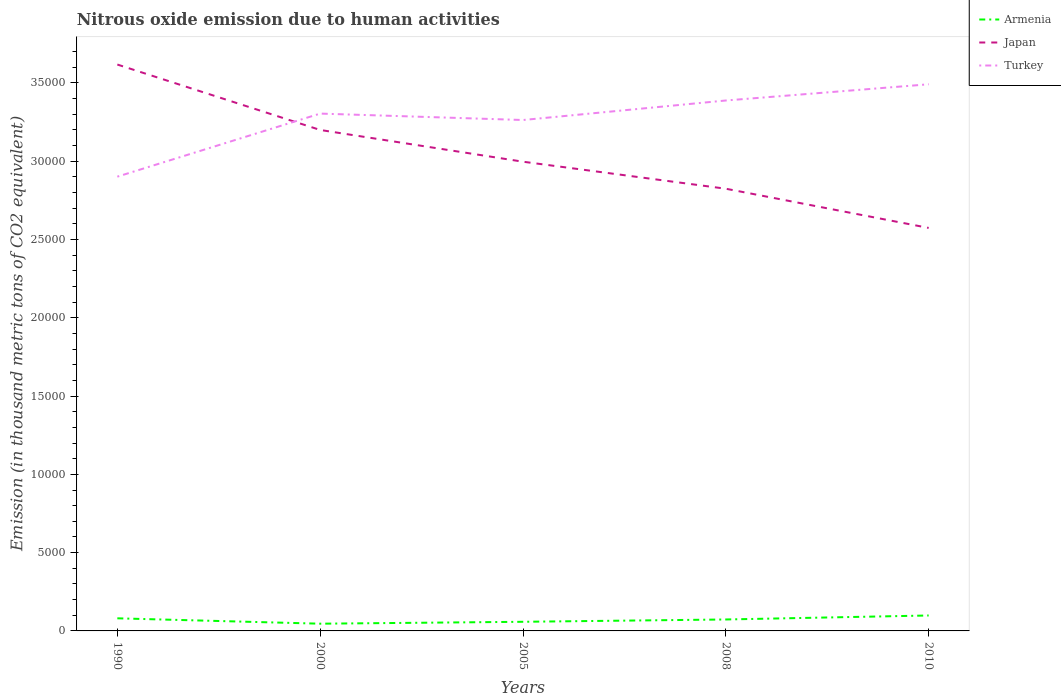How many different coloured lines are there?
Make the answer very short. 3. Does the line corresponding to Japan intersect with the line corresponding to Armenia?
Provide a succinct answer. No. Is the number of lines equal to the number of legend labels?
Your response must be concise. Yes. Across all years, what is the maximum amount of nitrous oxide emitted in Armenia?
Keep it short and to the point. 461.6. In which year was the amount of nitrous oxide emitted in Armenia maximum?
Provide a short and direct response. 2000. What is the total amount of nitrous oxide emitted in Japan in the graph?
Offer a very short reply. 1725.6. What is the difference between the highest and the second highest amount of nitrous oxide emitted in Turkey?
Ensure brevity in your answer.  5899.6. What is the difference between the highest and the lowest amount of nitrous oxide emitted in Turkey?
Give a very brief answer. 3. Is the amount of nitrous oxide emitted in Japan strictly greater than the amount of nitrous oxide emitted in Turkey over the years?
Your response must be concise. No. How many years are there in the graph?
Keep it short and to the point. 5. Are the values on the major ticks of Y-axis written in scientific E-notation?
Your answer should be compact. No. Does the graph contain any zero values?
Your response must be concise. No. How many legend labels are there?
Ensure brevity in your answer.  3. How are the legend labels stacked?
Offer a terse response. Vertical. What is the title of the graph?
Make the answer very short. Nitrous oxide emission due to human activities. What is the label or title of the X-axis?
Your answer should be very brief. Years. What is the label or title of the Y-axis?
Your response must be concise. Emission (in thousand metric tons of CO2 equivalent). What is the Emission (in thousand metric tons of CO2 equivalent) of Armenia in 1990?
Give a very brief answer. 805. What is the Emission (in thousand metric tons of CO2 equivalent) of Japan in 1990?
Provide a short and direct response. 3.62e+04. What is the Emission (in thousand metric tons of CO2 equivalent) in Turkey in 1990?
Your answer should be compact. 2.90e+04. What is the Emission (in thousand metric tons of CO2 equivalent) in Armenia in 2000?
Provide a succinct answer. 461.6. What is the Emission (in thousand metric tons of CO2 equivalent) of Japan in 2000?
Give a very brief answer. 3.20e+04. What is the Emission (in thousand metric tons of CO2 equivalent) of Turkey in 2000?
Provide a short and direct response. 3.30e+04. What is the Emission (in thousand metric tons of CO2 equivalent) in Armenia in 2005?
Keep it short and to the point. 583.5. What is the Emission (in thousand metric tons of CO2 equivalent) in Japan in 2005?
Provide a short and direct response. 3.00e+04. What is the Emission (in thousand metric tons of CO2 equivalent) of Turkey in 2005?
Give a very brief answer. 3.26e+04. What is the Emission (in thousand metric tons of CO2 equivalent) of Armenia in 2008?
Give a very brief answer. 731.4. What is the Emission (in thousand metric tons of CO2 equivalent) in Japan in 2008?
Your answer should be compact. 2.82e+04. What is the Emission (in thousand metric tons of CO2 equivalent) in Turkey in 2008?
Give a very brief answer. 3.39e+04. What is the Emission (in thousand metric tons of CO2 equivalent) in Armenia in 2010?
Offer a very short reply. 985.9. What is the Emission (in thousand metric tons of CO2 equivalent) of Japan in 2010?
Offer a terse response. 2.57e+04. What is the Emission (in thousand metric tons of CO2 equivalent) of Turkey in 2010?
Your response must be concise. 3.49e+04. Across all years, what is the maximum Emission (in thousand metric tons of CO2 equivalent) in Armenia?
Provide a short and direct response. 985.9. Across all years, what is the maximum Emission (in thousand metric tons of CO2 equivalent) of Japan?
Your answer should be compact. 3.62e+04. Across all years, what is the maximum Emission (in thousand metric tons of CO2 equivalent) of Turkey?
Make the answer very short. 3.49e+04. Across all years, what is the minimum Emission (in thousand metric tons of CO2 equivalent) of Armenia?
Your answer should be very brief. 461.6. Across all years, what is the minimum Emission (in thousand metric tons of CO2 equivalent) of Japan?
Keep it short and to the point. 2.57e+04. Across all years, what is the minimum Emission (in thousand metric tons of CO2 equivalent) in Turkey?
Make the answer very short. 2.90e+04. What is the total Emission (in thousand metric tons of CO2 equivalent) in Armenia in the graph?
Give a very brief answer. 3567.4. What is the total Emission (in thousand metric tons of CO2 equivalent) of Japan in the graph?
Provide a succinct answer. 1.52e+05. What is the total Emission (in thousand metric tons of CO2 equivalent) of Turkey in the graph?
Offer a terse response. 1.63e+05. What is the difference between the Emission (in thousand metric tons of CO2 equivalent) in Armenia in 1990 and that in 2000?
Provide a short and direct response. 343.4. What is the difference between the Emission (in thousand metric tons of CO2 equivalent) in Japan in 1990 and that in 2000?
Provide a short and direct response. 4179.1. What is the difference between the Emission (in thousand metric tons of CO2 equivalent) of Turkey in 1990 and that in 2000?
Ensure brevity in your answer.  -4027.6. What is the difference between the Emission (in thousand metric tons of CO2 equivalent) of Armenia in 1990 and that in 2005?
Your answer should be compact. 221.5. What is the difference between the Emission (in thousand metric tons of CO2 equivalent) in Japan in 1990 and that in 2005?
Provide a succinct answer. 6206.6. What is the difference between the Emission (in thousand metric tons of CO2 equivalent) in Turkey in 1990 and that in 2005?
Your answer should be compact. -3617.4. What is the difference between the Emission (in thousand metric tons of CO2 equivalent) in Armenia in 1990 and that in 2008?
Your answer should be very brief. 73.6. What is the difference between the Emission (in thousand metric tons of CO2 equivalent) in Japan in 1990 and that in 2008?
Your answer should be very brief. 7932.2. What is the difference between the Emission (in thousand metric tons of CO2 equivalent) in Turkey in 1990 and that in 2008?
Keep it short and to the point. -4864.2. What is the difference between the Emission (in thousand metric tons of CO2 equivalent) in Armenia in 1990 and that in 2010?
Provide a short and direct response. -180.9. What is the difference between the Emission (in thousand metric tons of CO2 equivalent) in Japan in 1990 and that in 2010?
Your answer should be compact. 1.04e+04. What is the difference between the Emission (in thousand metric tons of CO2 equivalent) of Turkey in 1990 and that in 2010?
Provide a short and direct response. -5899.6. What is the difference between the Emission (in thousand metric tons of CO2 equivalent) in Armenia in 2000 and that in 2005?
Keep it short and to the point. -121.9. What is the difference between the Emission (in thousand metric tons of CO2 equivalent) in Japan in 2000 and that in 2005?
Offer a terse response. 2027.5. What is the difference between the Emission (in thousand metric tons of CO2 equivalent) in Turkey in 2000 and that in 2005?
Provide a succinct answer. 410.2. What is the difference between the Emission (in thousand metric tons of CO2 equivalent) in Armenia in 2000 and that in 2008?
Your answer should be compact. -269.8. What is the difference between the Emission (in thousand metric tons of CO2 equivalent) of Japan in 2000 and that in 2008?
Your answer should be compact. 3753.1. What is the difference between the Emission (in thousand metric tons of CO2 equivalent) of Turkey in 2000 and that in 2008?
Your response must be concise. -836.6. What is the difference between the Emission (in thousand metric tons of CO2 equivalent) of Armenia in 2000 and that in 2010?
Ensure brevity in your answer.  -524.3. What is the difference between the Emission (in thousand metric tons of CO2 equivalent) of Japan in 2000 and that in 2010?
Make the answer very short. 6256.2. What is the difference between the Emission (in thousand metric tons of CO2 equivalent) in Turkey in 2000 and that in 2010?
Your answer should be very brief. -1872. What is the difference between the Emission (in thousand metric tons of CO2 equivalent) in Armenia in 2005 and that in 2008?
Ensure brevity in your answer.  -147.9. What is the difference between the Emission (in thousand metric tons of CO2 equivalent) in Japan in 2005 and that in 2008?
Ensure brevity in your answer.  1725.6. What is the difference between the Emission (in thousand metric tons of CO2 equivalent) of Turkey in 2005 and that in 2008?
Ensure brevity in your answer.  -1246.8. What is the difference between the Emission (in thousand metric tons of CO2 equivalent) of Armenia in 2005 and that in 2010?
Your answer should be very brief. -402.4. What is the difference between the Emission (in thousand metric tons of CO2 equivalent) of Japan in 2005 and that in 2010?
Your answer should be very brief. 4228.7. What is the difference between the Emission (in thousand metric tons of CO2 equivalent) of Turkey in 2005 and that in 2010?
Provide a short and direct response. -2282.2. What is the difference between the Emission (in thousand metric tons of CO2 equivalent) of Armenia in 2008 and that in 2010?
Your answer should be compact. -254.5. What is the difference between the Emission (in thousand metric tons of CO2 equivalent) in Japan in 2008 and that in 2010?
Provide a short and direct response. 2503.1. What is the difference between the Emission (in thousand metric tons of CO2 equivalent) in Turkey in 2008 and that in 2010?
Your response must be concise. -1035.4. What is the difference between the Emission (in thousand metric tons of CO2 equivalent) in Armenia in 1990 and the Emission (in thousand metric tons of CO2 equivalent) in Japan in 2000?
Provide a succinct answer. -3.12e+04. What is the difference between the Emission (in thousand metric tons of CO2 equivalent) in Armenia in 1990 and the Emission (in thousand metric tons of CO2 equivalent) in Turkey in 2000?
Your answer should be compact. -3.22e+04. What is the difference between the Emission (in thousand metric tons of CO2 equivalent) in Japan in 1990 and the Emission (in thousand metric tons of CO2 equivalent) in Turkey in 2000?
Offer a terse response. 3133.3. What is the difference between the Emission (in thousand metric tons of CO2 equivalent) of Armenia in 1990 and the Emission (in thousand metric tons of CO2 equivalent) of Japan in 2005?
Provide a succinct answer. -2.92e+04. What is the difference between the Emission (in thousand metric tons of CO2 equivalent) of Armenia in 1990 and the Emission (in thousand metric tons of CO2 equivalent) of Turkey in 2005?
Ensure brevity in your answer.  -3.18e+04. What is the difference between the Emission (in thousand metric tons of CO2 equivalent) of Japan in 1990 and the Emission (in thousand metric tons of CO2 equivalent) of Turkey in 2005?
Give a very brief answer. 3543.5. What is the difference between the Emission (in thousand metric tons of CO2 equivalent) of Armenia in 1990 and the Emission (in thousand metric tons of CO2 equivalent) of Japan in 2008?
Your response must be concise. -2.74e+04. What is the difference between the Emission (in thousand metric tons of CO2 equivalent) in Armenia in 1990 and the Emission (in thousand metric tons of CO2 equivalent) in Turkey in 2008?
Make the answer very short. -3.31e+04. What is the difference between the Emission (in thousand metric tons of CO2 equivalent) of Japan in 1990 and the Emission (in thousand metric tons of CO2 equivalent) of Turkey in 2008?
Keep it short and to the point. 2296.7. What is the difference between the Emission (in thousand metric tons of CO2 equivalent) of Armenia in 1990 and the Emission (in thousand metric tons of CO2 equivalent) of Japan in 2010?
Ensure brevity in your answer.  -2.49e+04. What is the difference between the Emission (in thousand metric tons of CO2 equivalent) in Armenia in 1990 and the Emission (in thousand metric tons of CO2 equivalent) in Turkey in 2010?
Your answer should be compact. -3.41e+04. What is the difference between the Emission (in thousand metric tons of CO2 equivalent) of Japan in 1990 and the Emission (in thousand metric tons of CO2 equivalent) of Turkey in 2010?
Your response must be concise. 1261.3. What is the difference between the Emission (in thousand metric tons of CO2 equivalent) of Armenia in 2000 and the Emission (in thousand metric tons of CO2 equivalent) of Japan in 2005?
Provide a succinct answer. -2.95e+04. What is the difference between the Emission (in thousand metric tons of CO2 equivalent) in Armenia in 2000 and the Emission (in thousand metric tons of CO2 equivalent) in Turkey in 2005?
Your answer should be compact. -3.22e+04. What is the difference between the Emission (in thousand metric tons of CO2 equivalent) of Japan in 2000 and the Emission (in thousand metric tons of CO2 equivalent) of Turkey in 2005?
Ensure brevity in your answer.  -635.6. What is the difference between the Emission (in thousand metric tons of CO2 equivalent) in Armenia in 2000 and the Emission (in thousand metric tons of CO2 equivalent) in Japan in 2008?
Offer a very short reply. -2.78e+04. What is the difference between the Emission (in thousand metric tons of CO2 equivalent) of Armenia in 2000 and the Emission (in thousand metric tons of CO2 equivalent) of Turkey in 2008?
Offer a very short reply. -3.34e+04. What is the difference between the Emission (in thousand metric tons of CO2 equivalent) in Japan in 2000 and the Emission (in thousand metric tons of CO2 equivalent) in Turkey in 2008?
Give a very brief answer. -1882.4. What is the difference between the Emission (in thousand metric tons of CO2 equivalent) in Armenia in 2000 and the Emission (in thousand metric tons of CO2 equivalent) in Japan in 2010?
Keep it short and to the point. -2.53e+04. What is the difference between the Emission (in thousand metric tons of CO2 equivalent) in Armenia in 2000 and the Emission (in thousand metric tons of CO2 equivalent) in Turkey in 2010?
Offer a terse response. -3.45e+04. What is the difference between the Emission (in thousand metric tons of CO2 equivalent) in Japan in 2000 and the Emission (in thousand metric tons of CO2 equivalent) in Turkey in 2010?
Provide a succinct answer. -2917.8. What is the difference between the Emission (in thousand metric tons of CO2 equivalent) of Armenia in 2005 and the Emission (in thousand metric tons of CO2 equivalent) of Japan in 2008?
Give a very brief answer. -2.77e+04. What is the difference between the Emission (in thousand metric tons of CO2 equivalent) of Armenia in 2005 and the Emission (in thousand metric tons of CO2 equivalent) of Turkey in 2008?
Give a very brief answer. -3.33e+04. What is the difference between the Emission (in thousand metric tons of CO2 equivalent) in Japan in 2005 and the Emission (in thousand metric tons of CO2 equivalent) in Turkey in 2008?
Offer a terse response. -3909.9. What is the difference between the Emission (in thousand metric tons of CO2 equivalent) of Armenia in 2005 and the Emission (in thousand metric tons of CO2 equivalent) of Japan in 2010?
Make the answer very short. -2.52e+04. What is the difference between the Emission (in thousand metric tons of CO2 equivalent) in Armenia in 2005 and the Emission (in thousand metric tons of CO2 equivalent) in Turkey in 2010?
Ensure brevity in your answer.  -3.43e+04. What is the difference between the Emission (in thousand metric tons of CO2 equivalent) in Japan in 2005 and the Emission (in thousand metric tons of CO2 equivalent) in Turkey in 2010?
Make the answer very short. -4945.3. What is the difference between the Emission (in thousand metric tons of CO2 equivalent) of Armenia in 2008 and the Emission (in thousand metric tons of CO2 equivalent) of Japan in 2010?
Keep it short and to the point. -2.50e+04. What is the difference between the Emission (in thousand metric tons of CO2 equivalent) of Armenia in 2008 and the Emission (in thousand metric tons of CO2 equivalent) of Turkey in 2010?
Offer a very short reply. -3.42e+04. What is the difference between the Emission (in thousand metric tons of CO2 equivalent) of Japan in 2008 and the Emission (in thousand metric tons of CO2 equivalent) of Turkey in 2010?
Keep it short and to the point. -6670.9. What is the average Emission (in thousand metric tons of CO2 equivalent) in Armenia per year?
Keep it short and to the point. 713.48. What is the average Emission (in thousand metric tons of CO2 equivalent) of Japan per year?
Provide a short and direct response. 3.04e+04. What is the average Emission (in thousand metric tons of CO2 equivalent) in Turkey per year?
Make the answer very short. 3.27e+04. In the year 1990, what is the difference between the Emission (in thousand metric tons of CO2 equivalent) of Armenia and Emission (in thousand metric tons of CO2 equivalent) of Japan?
Your answer should be compact. -3.54e+04. In the year 1990, what is the difference between the Emission (in thousand metric tons of CO2 equivalent) in Armenia and Emission (in thousand metric tons of CO2 equivalent) in Turkey?
Ensure brevity in your answer.  -2.82e+04. In the year 1990, what is the difference between the Emission (in thousand metric tons of CO2 equivalent) of Japan and Emission (in thousand metric tons of CO2 equivalent) of Turkey?
Your response must be concise. 7160.9. In the year 2000, what is the difference between the Emission (in thousand metric tons of CO2 equivalent) of Armenia and Emission (in thousand metric tons of CO2 equivalent) of Japan?
Keep it short and to the point. -3.15e+04. In the year 2000, what is the difference between the Emission (in thousand metric tons of CO2 equivalent) of Armenia and Emission (in thousand metric tons of CO2 equivalent) of Turkey?
Provide a short and direct response. -3.26e+04. In the year 2000, what is the difference between the Emission (in thousand metric tons of CO2 equivalent) in Japan and Emission (in thousand metric tons of CO2 equivalent) in Turkey?
Provide a short and direct response. -1045.8. In the year 2005, what is the difference between the Emission (in thousand metric tons of CO2 equivalent) in Armenia and Emission (in thousand metric tons of CO2 equivalent) in Japan?
Offer a very short reply. -2.94e+04. In the year 2005, what is the difference between the Emission (in thousand metric tons of CO2 equivalent) of Armenia and Emission (in thousand metric tons of CO2 equivalent) of Turkey?
Provide a succinct answer. -3.20e+04. In the year 2005, what is the difference between the Emission (in thousand metric tons of CO2 equivalent) of Japan and Emission (in thousand metric tons of CO2 equivalent) of Turkey?
Offer a terse response. -2663.1. In the year 2008, what is the difference between the Emission (in thousand metric tons of CO2 equivalent) in Armenia and Emission (in thousand metric tons of CO2 equivalent) in Japan?
Provide a short and direct response. -2.75e+04. In the year 2008, what is the difference between the Emission (in thousand metric tons of CO2 equivalent) in Armenia and Emission (in thousand metric tons of CO2 equivalent) in Turkey?
Provide a short and direct response. -3.31e+04. In the year 2008, what is the difference between the Emission (in thousand metric tons of CO2 equivalent) of Japan and Emission (in thousand metric tons of CO2 equivalent) of Turkey?
Ensure brevity in your answer.  -5635.5. In the year 2010, what is the difference between the Emission (in thousand metric tons of CO2 equivalent) in Armenia and Emission (in thousand metric tons of CO2 equivalent) in Japan?
Your response must be concise. -2.48e+04. In the year 2010, what is the difference between the Emission (in thousand metric tons of CO2 equivalent) of Armenia and Emission (in thousand metric tons of CO2 equivalent) of Turkey?
Provide a short and direct response. -3.39e+04. In the year 2010, what is the difference between the Emission (in thousand metric tons of CO2 equivalent) of Japan and Emission (in thousand metric tons of CO2 equivalent) of Turkey?
Ensure brevity in your answer.  -9174. What is the ratio of the Emission (in thousand metric tons of CO2 equivalent) of Armenia in 1990 to that in 2000?
Offer a terse response. 1.74. What is the ratio of the Emission (in thousand metric tons of CO2 equivalent) in Japan in 1990 to that in 2000?
Your answer should be very brief. 1.13. What is the ratio of the Emission (in thousand metric tons of CO2 equivalent) of Turkey in 1990 to that in 2000?
Offer a very short reply. 0.88. What is the ratio of the Emission (in thousand metric tons of CO2 equivalent) of Armenia in 1990 to that in 2005?
Offer a very short reply. 1.38. What is the ratio of the Emission (in thousand metric tons of CO2 equivalent) of Japan in 1990 to that in 2005?
Keep it short and to the point. 1.21. What is the ratio of the Emission (in thousand metric tons of CO2 equivalent) of Turkey in 1990 to that in 2005?
Offer a terse response. 0.89. What is the ratio of the Emission (in thousand metric tons of CO2 equivalent) of Armenia in 1990 to that in 2008?
Offer a terse response. 1.1. What is the ratio of the Emission (in thousand metric tons of CO2 equivalent) in Japan in 1990 to that in 2008?
Give a very brief answer. 1.28. What is the ratio of the Emission (in thousand metric tons of CO2 equivalent) in Turkey in 1990 to that in 2008?
Your answer should be very brief. 0.86. What is the ratio of the Emission (in thousand metric tons of CO2 equivalent) in Armenia in 1990 to that in 2010?
Your response must be concise. 0.82. What is the ratio of the Emission (in thousand metric tons of CO2 equivalent) in Japan in 1990 to that in 2010?
Your answer should be compact. 1.41. What is the ratio of the Emission (in thousand metric tons of CO2 equivalent) in Turkey in 1990 to that in 2010?
Ensure brevity in your answer.  0.83. What is the ratio of the Emission (in thousand metric tons of CO2 equivalent) in Armenia in 2000 to that in 2005?
Your answer should be very brief. 0.79. What is the ratio of the Emission (in thousand metric tons of CO2 equivalent) of Japan in 2000 to that in 2005?
Your answer should be compact. 1.07. What is the ratio of the Emission (in thousand metric tons of CO2 equivalent) in Turkey in 2000 to that in 2005?
Keep it short and to the point. 1.01. What is the ratio of the Emission (in thousand metric tons of CO2 equivalent) in Armenia in 2000 to that in 2008?
Your answer should be compact. 0.63. What is the ratio of the Emission (in thousand metric tons of CO2 equivalent) of Japan in 2000 to that in 2008?
Offer a terse response. 1.13. What is the ratio of the Emission (in thousand metric tons of CO2 equivalent) of Turkey in 2000 to that in 2008?
Keep it short and to the point. 0.98. What is the ratio of the Emission (in thousand metric tons of CO2 equivalent) in Armenia in 2000 to that in 2010?
Your answer should be compact. 0.47. What is the ratio of the Emission (in thousand metric tons of CO2 equivalent) in Japan in 2000 to that in 2010?
Ensure brevity in your answer.  1.24. What is the ratio of the Emission (in thousand metric tons of CO2 equivalent) in Turkey in 2000 to that in 2010?
Provide a succinct answer. 0.95. What is the ratio of the Emission (in thousand metric tons of CO2 equivalent) of Armenia in 2005 to that in 2008?
Provide a short and direct response. 0.8. What is the ratio of the Emission (in thousand metric tons of CO2 equivalent) in Japan in 2005 to that in 2008?
Ensure brevity in your answer.  1.06. What is the ratio of the Emission (in thousand metric tons of CO2 equivalent) of Turkey in 2005 to that in 2008?
Your answer should be very brief. 0.96. What is the ratio of the Emission (in thousand metric tons of CO2 equivalent) in Armenia in 2005 to that in 2010?
Provide a succinct answer. 0.59. What is the ratio of the Emission (in thousand metric tons of CO2 equivalent) in Japan in 2005 to that in 2010?
Ensure brevity in your answer.  1.16. What is the ratio of the Emission (in thousand metric tons of CO2 equivalent) in Turkey in 2005 to that in 2010?
Provide a short and direct response. 0.93. What is the ratio of the Emission (in thousand metric tons of CO2 equivalent) of Armenia in 2008 to that in 2010?
Offer a terse response. 0.74. What is the ratio of the Emission (in thousand metric tons of CO2 equivalent) of Japan in 2008 to that in 2010?
Offer a terse response. 1.1. What is the ratio of the Emission (in thousand metric tons of CO2 equivalent) of Turkey in 2008 to that in 2010?
Offer a very short reply. 0.97. What is the difference between the highest and the second highest Emission (in thousand metric tons of CO2 equivalent) in Armenia?
Offer a very short reply. 180.9. What is the difference between the highest and the second highest Emission (in thousand metric tons of CO2 equivalent) in Japan?
Offer a terse response. 4179.1. What is the difference between the highest and the second highest Emission (in thousand metric tons of CO2 equivalent) in Turkey?
Offer a very short reply. 1035.4. What is the difference between the highest and the lowest Emission (in thousand metric tons of CO2 equivalent) in Armenia?
Your answer should be compact. 524.3. What is the difference between the highest and the lowest Emission (in thousand metric tons of CO2 equivalent) in Japan?
Your answer should be compact. 1.04e+04. What is the difference between the highest and the lowest Emission (in thousand metric tons of CO2 equivalent) in Turkey?
Your answer should be very brief. 5899.6. 